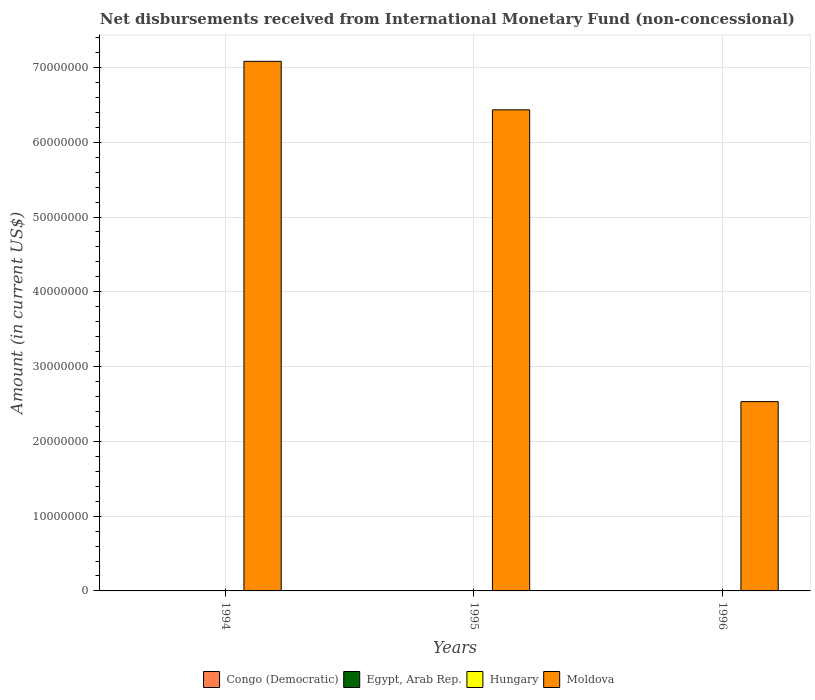How many bars are there on the 2nd tick from the left?
Provide a succinct answer. 1. What is the amount of disbursements received from International Monetary Fund in Egypt, Arab Rep. in 1995?
Give a very brief answer. 0. Across all years, what is the maximum amount of disbursements received from International Monetary Fund in Moldova?
Offer a terse response. 7.08e+07. What is the difference between the amount of disbursements received from International Monetary Fund in Moldova in 1994 and that in 1995?
Make the answer very short. 6.48e+06. What is the difference between the amount of disbursements received from International Monetary Fund in Moldova in 1996 and the amount of disbursements received from International Monetary Fund in Egypt, Arab Rep. in 1994?
Make the answer very short. 2.53e+07. What is the ratio of the amount of disbursements received from International Monetary Fund in Moldova in 1995 to that in 1996?
Offer a very short reply. 2.54. What is the difference between the highest and the lowest amount of disbursements received from International Monetary Fund in Moldova?
Provide a succinct answer. 4.55e+07. Is the sum of the amount of disbursements received from International Monetary Fund in Moldova in 1994 and 1995 greater than the maximum amount of disbursements received from International Monetary Fund in Egypt, Arab Rep. across all years?
Offer a terse response. Yes. Is it the case that in every year, the sum of the amount of disbursements received from International Monetary Fund in Congo (Democratic) and amount of disbursements received from International Monetary Fund in Moldova is greater than the sum of amount of disbursements received from International Monetary Fund in Egypt, Arab Rep. and amount of disbursements received from International Monetary Fund in Hungary?
Your answer should be very brief. Yes. Is it the case that in every year, the sum of the amount of disbursements received from International Monetary Fund in Congo (Democratic) and amount of disbursements received from International Monetary Fund in Hungary is greater than the amount of disbursements received from International Monetary Fund in Egypt, Arab Rep.?
Make the answer very short. No. How many bars are there?
Your answer should be compact. 3. Are all the bars in the graph horizontal?
Give a very brief answer. No. How many years are there in the graph?
Offer a very short reply. 3. What is the difference between two consecutive major ticks on the Y-axis?
Offer a very short reply. 1.00e+07. Are the values on the major ticks of Y-axis written in scientific E-notation?
Keep it short and to the point. No. Does the graph contain any zero values?
Your response must be concise. Yes. Does the graph contain grids?
Keep it short and to the point. Yes. How many legend labels are there?
Give a very brief answer. 4. What is the title of the graph?
Your answer should be compact. Net disbursements received from International Monetary Fund (non-concessional). What is the label or title of the X-axis?
Ensure brevity in your answer.  Years. What is the Amount (in current US$) of Hungary in 1994?
Ensure brevity in your answer.  0. What is the Amount (in current US$) in Moldova in 1994?
Give a very brief answer. 7.08e+07. What is the Amount (in current US$) of Congo (Democratic) in 1995?
Provide a short and direct response. 0. What is the Amount (in current US$) in Hungary in 1995?
Offer a very short reply. 0. What is the Amount (in current US$) of Moldova in 1995?
Your answer should be compact. 6.43e+07. What is the Amount (in current US$) in Hungary in 1996?
Keep it short and to the point. 0. What is the Amount (in current US$) in Moldova in 1996?
Your response must be concise. 2.53e+07. Across all years, what is the maximum Amount (in current US$) of Moldova?
Ensure brevity in your answer.  7.08e+07. Across all years, what is the minimum Amount (in current US$) of Moldova?
Offer a very short reply. 2.53e+07. What is the total Amount (in current US$) of Congo (Democratic) in the graph?
Give a very brief answer. 0. What is the total Amount (in current US$) in Hungary in the graph?
Your response must be concise. 0. What is the total Amount (in current US$) of Moldova in the graph?
Keep it short and to the point. 1.60e+08. What is the difference between the Amount (in current US$) of Moldova in 1994 and that in 1995?
Make the answer very short. 6.48e+06. What is the difference between the Amount (in current US$) in Moldova in 1994 and that in 1996?
Your answer should be compact. 4.55e+07. What is the difference between the Amount (in current US$) in Moldova in 1995 and that in 1996?
Your answer should be compact. 3.90e+07. What is the average Amount (in current US$) in Congo (Democratic) per year?
Give a very brief answer. 0. What is the average Amount (in current US$) of Hungary per year?
Make the answer very short. 0. What is the average Amount (in current US$) of Moldova per year?
Your answer should be compact. 5.35e+07. What is the ratio of the Amount (in current US$) of Moldova in 1994 to that in 1995?
Offer a terse response. 1.1. What is the ratio of the Amount (in current US$) in Moldova in 1994 to that in 1996?
Provide a short and direct response. 2.8. What is the ratio of the Amount (in current US$) of Moldova in 1995 to that in 1996?
Provide a short and direct response. 2.54. What is the difference between the highest and the second highest Amount (in current US$) in Moldova?
Your response must be concise. 6.48e+06. What is the difference between the highest and the lowest Amount (in current US$) in Moldova?
Offer a terse response. 4.55e+07. 